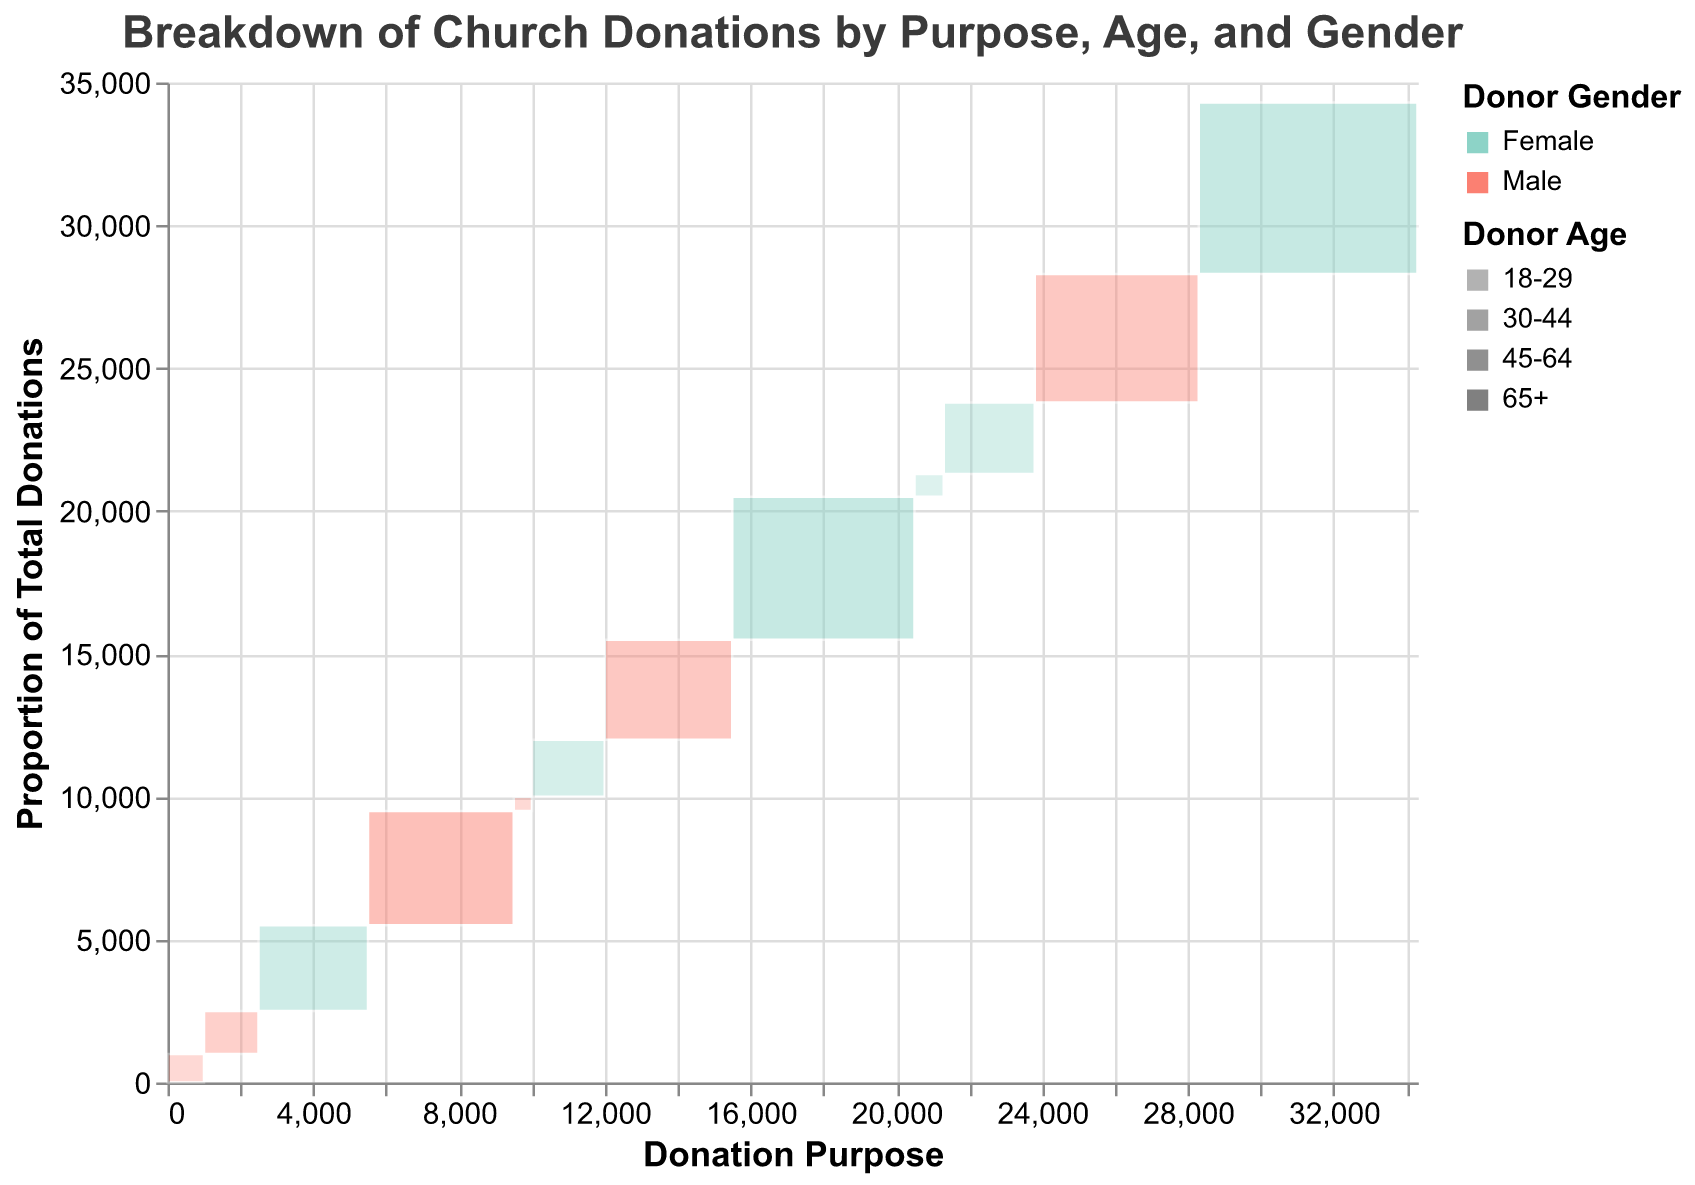What is the title of the figure? The title of any figure is typically placed at the top and is styled for prominence. In this case, the title reads "Breakdown of Church Donations by Purpose, Age, and Gender".
Answer: Breakdown of Church Donations by Purpose, Age, and Gender What are the three purposes for donations mentioned in the figure? By reading the legend or the labels in the figure, we can observe that the three purposes for donations are labelled as "Maintenance", "Charity", and "Missions".
Answer: Maintenance, Charity, Missions Which donor gender has the highest contribution to maintenance with ages 65+? First, locate the section of the plot that corresponds to "Maintenance" and "65+." The color associated with the gender categories indicates that the higher contribution is from the segment color for female (assuming "#fb8072" is female).
Answer: Female What is the total amount donated for missions by donors aged 65+ and 45-64 combined? To solve this, identify the donations for "Missions" by both age groups. For "Missions" and "65+", the amount is 6000, and for "Missions" and "45-64", it is 4500. Summing them up gives us 6000 + 4500.
Answer: 10,500 Compare the donations to charity by males aged 18-29 and females aged 45-64. Who donated more, and by how much? Identify the donations for "Charity" from both segments: "18-29 Male" donated 1000, and "45-64 Female" donated 3000. The difference is calculated as 3000 - 1000.
Answer: Females aged 45-64 donated more by 2000 Among the donations for missions, which age group of males contributed the least amount? For the "Missions" purpose, examine the contributions made by different age groups of males. The values are 4500 for "45-64" males and there is no listed donation from other male age groups. Therefore, 4500 is the only relevant amount.
Answer: 45-64 How does the magnitude of total donations by females aged 30-44 compare across maintenance, charity, and missions? To compare, find the "30-44" female donations for each purpose: 2000 for Maintenance, no data for Charity, and 2500 for Missions. Compare these amounts.
Answer: Higher for Missions (2500 vs 2000) Which combination of purpose and donor demographics resulted in the smallest donation, and what is its value? By reviewing all sections, we identify the smallest donation is for "Maintenance" by "18-29" males with a donation of 500.
Answer: Maintenance, 18-29 Male, 500 If you sum up the donations made by females across all purposes, what amount do they reach? Calculate the total for female donors for each purpose: Maintenance (5000 from 65+, 2000 from 30-44), Charity (3000 from 45-64), Missions (6000 from 65+, 2500 from 30-44, 800 from 18-29). Sum these values: 5000+2000+3000+6000+2500+800.
Answer: 19,300 